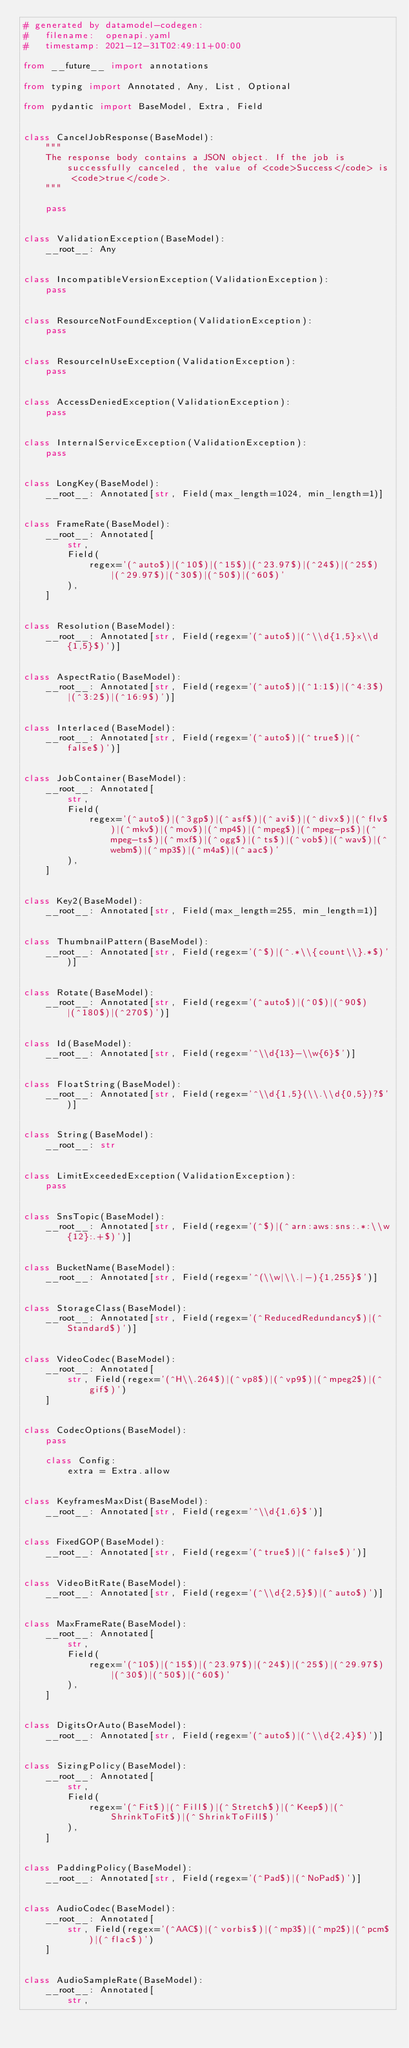<code> <loc_0><loc_0><loc_500><loc_500><_Python_># generated by datamodel-codegen:
#   filename:  openapi.yaml
#   timestamp: 2021-12-31T02:49:11+00:00

from __future__ import annotations

from typing import Annotated, Any, List, Optional

from pydantic import BaseModel, Extra, Field


class CancelJobResponse(BaseModel):
    """
    The response body contains a JSON object. If the job is successfully canceled, the value of <code>Success</code> is <code>true</code>.
    """

    pass


class ValidationException(BaseModel):
    __root__: Any


class IncompatibleVersionException(ValidationException):
    pass


class ResourceNotFoundException(ValidationException):
    pass


class ResourceInUseException(ValidationException):
    pass


class AccessDeniedException(ValidationException):
    pass


class InternalServiceException(ValidationException):
    pass


class LongKey(BaseModel):
    __root__: Annotated[str, Field(max_length=1024, min_length=1)]


class FrameRate(BaseModel):
    __root__: Annotated[
        str,
        Field(
            regex='(^auto$)|(^10$)|(^15$)|(^23.97$)|(^24$)|(^25$)|(^29.97$)|(^30$)|(^50$)|(^60$)'
        ),
    ]


class Resolution(BaseModel):
    __root__: Annotated[str, Field(regex='(^auto$)|(^\\d{1,5}x\\d{1,5}$)')]


class AspectRatio(BaseModel):
    __root__: Annotated[str, Field(regex='(^auto$)|(^1:1$)|(^4:3$)|(^3:2$)|(^16:9$)')]


class Interlaced(BaseModel):
    __root__: Annotated[str, Field(regex='(^auto$)|(^true$)|(^false$)')]


class JobContainer(BaseModel):
    __root__: Annotated[
        str,
        Field(
            regex='(^auto$)|(^3gp$)|(^asf$)|(^avi$)|(^divx$)|(^flv$)|(^mkv$)|(^mov$)|(^mp4$)|(^mpeg$)|(^mpeg-ps$)|(^mpeg-ts$)|(^mxf$)|(^ogg$)|(^ts$)|(^vob$)|(^wav$)|(^webm$)|(^mp3$)|(^m4a$)|(^aac$)'
        ),
    ]


class Key2(BaseModel):
    __root__: Annotated[str, Field(max_length=255, min_length=1)]


class ThumbnailPattern(BaseModel):
    __root__: Annotated[str, Field(regex='(^$)|(^.*\\{count\\}.*$)')]


class Rotate(BaseModel):
    __root__: Annotated[str, Field(regex='(^auto$)|(^0$)|(^90$)|(^180$)|(^270$)')]


class Id(BaseModel):
    __root__: Annotated[str, Field(regex='^\\d{13}-\\w{6}$')]


class FloatString(BaseModel):
    __root__: Annotated[str, Field(regex='^\\d{1,5}(\\.\\d{0,5})?$')]


class String(BaseModel):
    __root__: str


class LimitExceededException(ValidationException):
    pass


class SnsTopic(BaseModel):
    __root__: Annotated[str, Field(regex='(^$)|(^arn:aws:sns:.*:\\w{12}:.+$)')]


class BucketName(BaseModel):
    __root__: Annotated[str, Field(regex='^(\\w|\\.|-){1,255}$')]


class StorageClass(BaseModel):
    __root__: Annotated[str, Field(regex='(^ReducedRedundancy$)|(^Standard$)')]


class VideoCodec(BaseModel):
    __root__: Annotated[
        str, Field(regex='(^H\\.264$)|(^vp8$)|(^vp9$)|(^mpeg2$)|(^gif$)')
    ]


class CodecOptions(BaseModel):
    pass

    class Config:
        extra = Extra.allow


class KeyframesMaxDist(BaseModel):
    __root__: Annotated[str, Field(regex='^\\d{1,6}$')]


class FixedGOP(BaseModel):
    __root__: Annotated[str, Field(regex='(^true$)|(^false$)')]


class VideoBitRate(BaseModel):
    __root__: Annotated[str, Field(regex='(^\\d{2,5}$)|(^auto$)')]


class MaxFrameRate(BaseModel):
    __root__: Annotated[
        str,
        Field(
            regex='(^10$)|(^15$)|(^23.97$)|(^24$)|(^25$)|(^29.97$)|(^30$)|(^50$)|(^60$)'
        ),
    ]


class DigitsOrAuto(BaseModel):
    __root__: Annotated[str, Field(regex='(^auto$)|(^\\d{2,4}$)')]


class SizingPolicy(BaseModel):
    __root__: Annotated[
        str,
        Field(
            regex='(^Fit$)|(^Fill$)|(^Stretch$)|(^Keep$)|(^ShrinkToFit$)|(^ShrinkToFill$)'
        ),
    ]


class PaddingPolicy(BaseModel):
    __root__: Annotated[str, Field(regex='(^Pad$)|(^NoPad$)')]


class AudioCodec(BaseModel):
    __root__: Annotated[
        str, Field(regex='(^AAC$)|(^vorbis$)|(^mp3$)|(^mp2$)|(^pcm$)|(^flac$)')
    ]


class AudioSampleRate(BaseModel):
    __root__: Annotated[
        str,</code> 